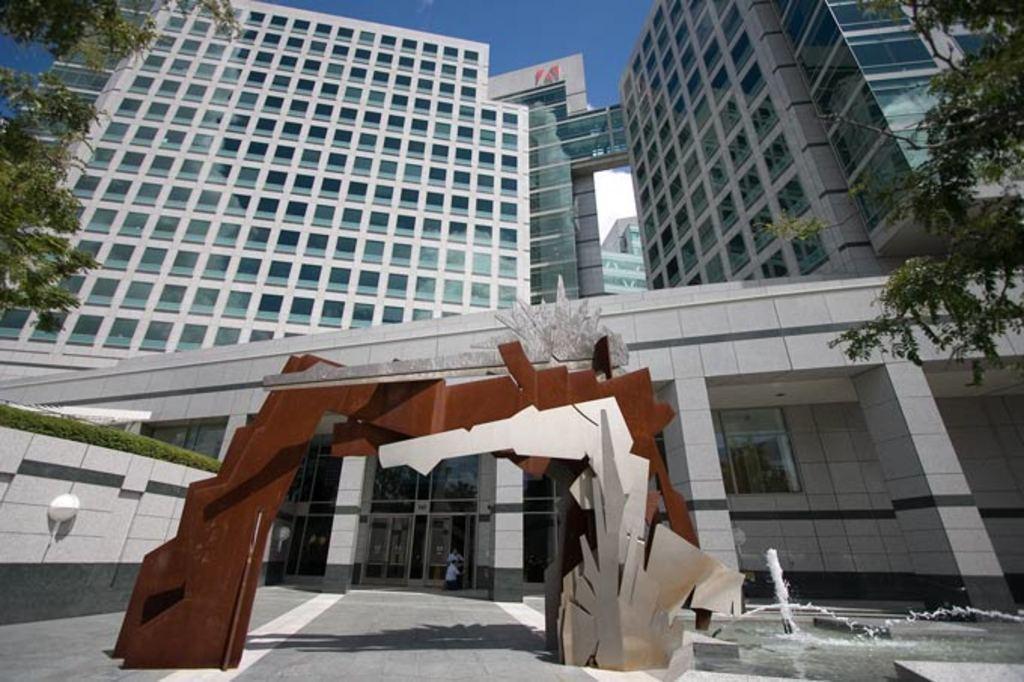Could you give a brief overview of what you see in this image? In this picture I can see the arch in front and I can see the fountain. In the background I can see the buildings, few trees and the grass on the left side of this picture. On the top of this picture I can see the sky. 